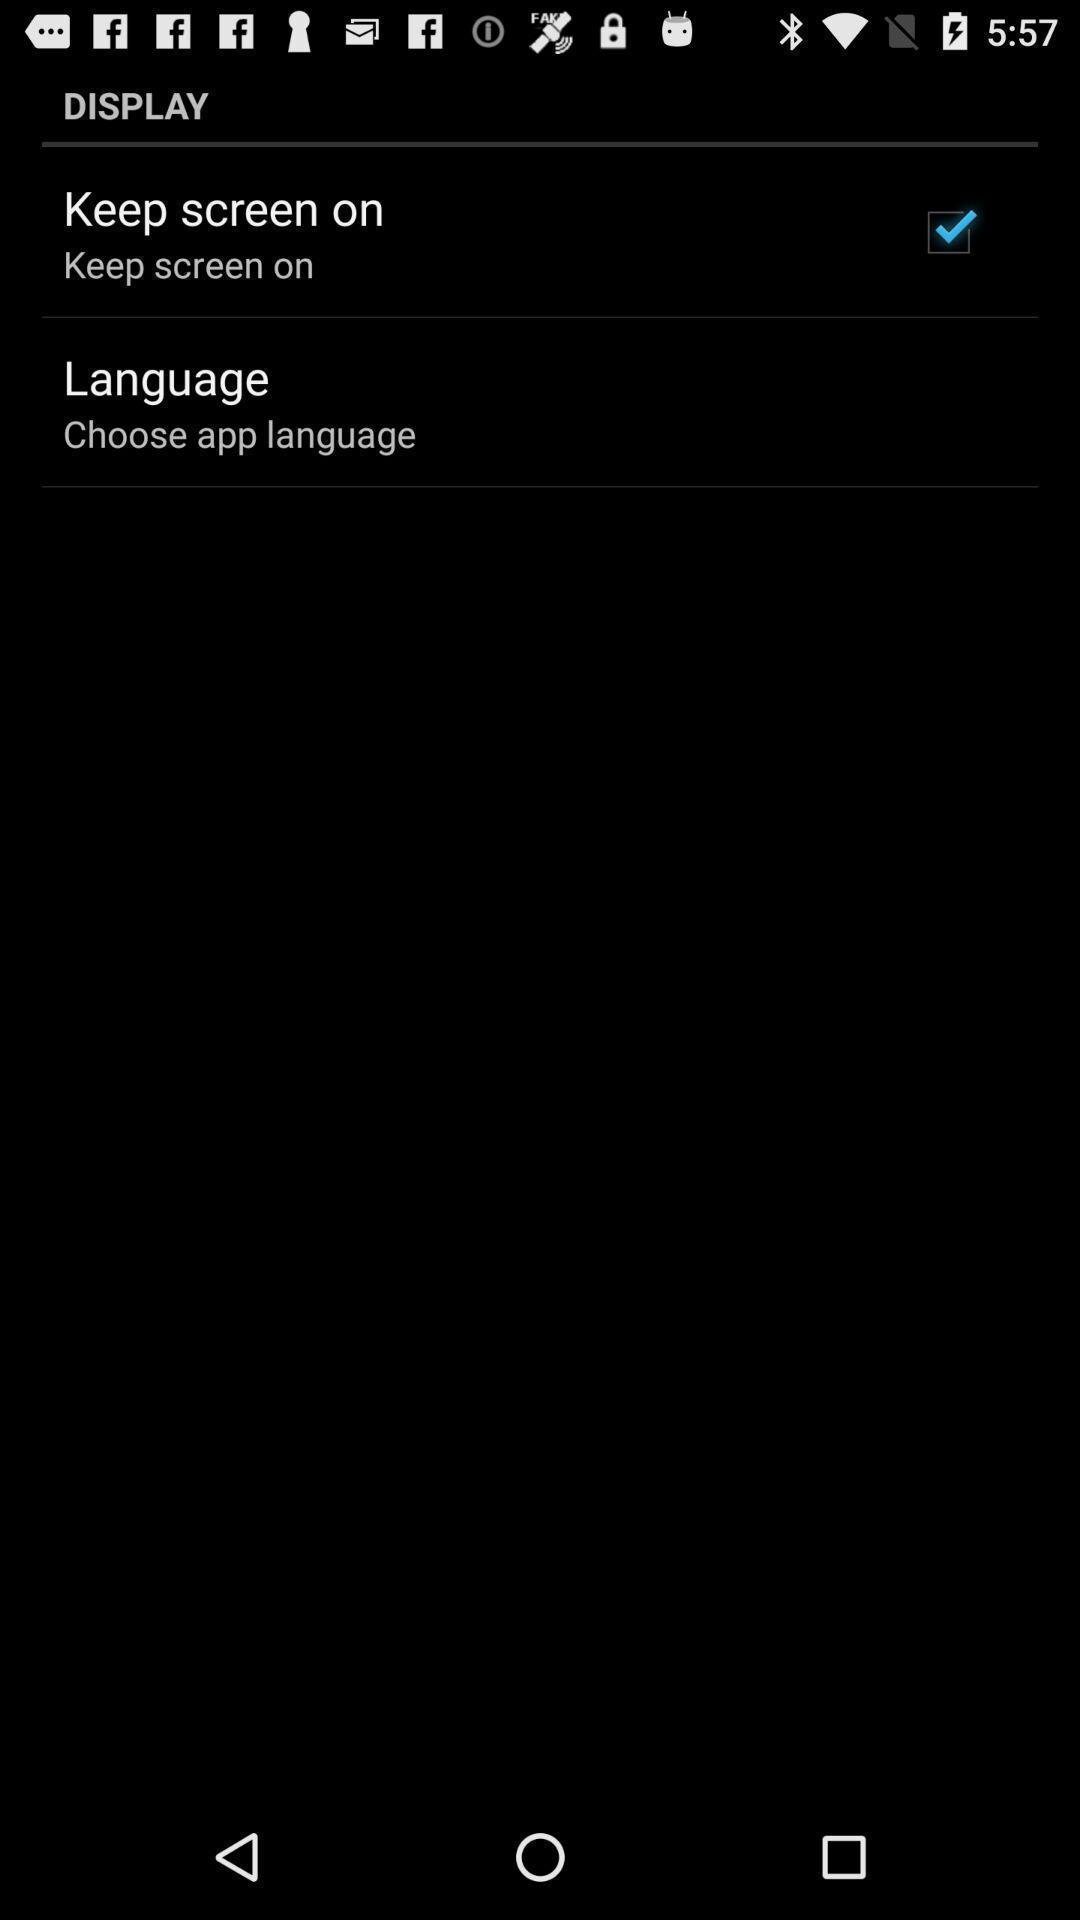Summarize the main components in this picture. Page showing display settings. 